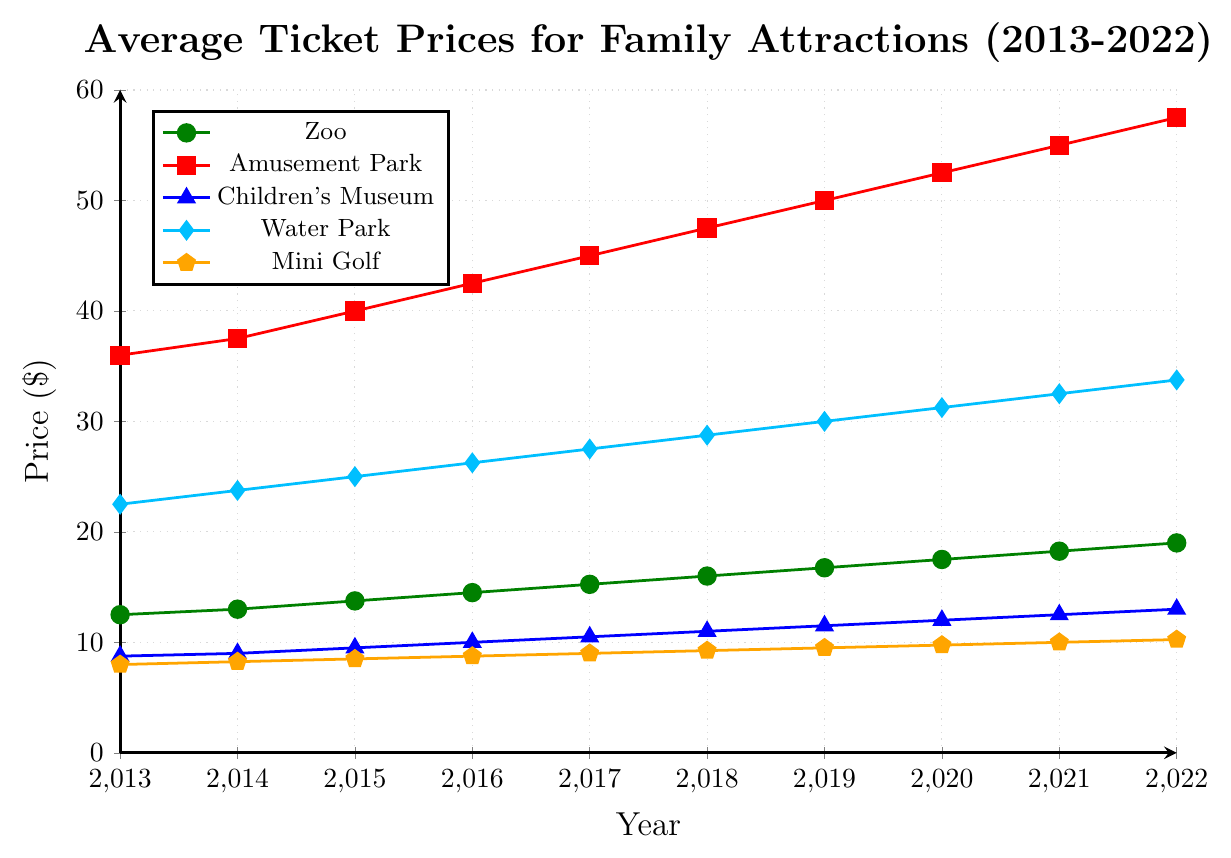What was the overall increase in the average ticket price for the Zoo from 2013 to 2022? The average ticket price for the Zoo in 2013 was $12.50, and it increased to $19.00 in 2022. To find the overall increase, subtract the price in 2013 from the price in 2022: $19.00 - $12.50 = $6.50.
Answer: $6.50 Which type of activity had the highest average ticket price in 2022? By looking at the figure, the Amusement Park had the highest average ticket price in 2022 at $57.50.
Answer: Amusement Park How much did the average ticket price for the Mini Golf increase from 2013 to 2022? The average ticket price for the Mini Golf in 2013 was $7.99, and it increased to $10.25 in 2022. Subtracting the price in 2013 from the price in 2022: $10.25 - $7.99 = $2.26.
Answer: $2.26 Which activity experienced the smallest increase in average ticket price over the decade? By comparing the values from 2013 to 2022 across all activities, the Children's Museum increased from $8.75 to $13.00, which is an increase of $4.25, the smallest among all activities.
Answer: Children's Museum What is the average ticket price for the Water Park in the years 2019 and 2020? The average ticket price for 2019 is $30.00 and for 2020 is $31.25. To find the average of these two years: ($30.00 + $31.25) / 2 = $30.625.
Answer: $30.625 Between which two consecutive years did the Amusement Park ticket prices increase the most? Examining the year-to-year increases in the Amusement Park prices: 
2013-2014: $1.51, 2014-2015: $2.49, 2015-2016: $2.51, 2016-2017: $2.49, 2017-2018: $2.51, 2018-2019: $2.49, 2019-2020: $2.51, 2020-2021: $2.49, 2021-2022: $2.51.
The largest increase occurred between 2015 and 2016 with $2.51.
Answer: 2015-2016 What was the percentage increase in the average ticket price for the Children's Museum from 2013 to 2022? The average ticket price for the Children's Museum in 2013 was $8.75, and it increased to $13.00 in 2022. To find the percentage increase, use the formula: ((13.00 - 8.75) / 8.75) * 100. This calculates to ((4.25 / 8.75) * 100) = 48.57%.
Answer: 48.57% Which activity had a higher average ticket price in 2016: Water Park or Zoo? In 2016, the average ticket price for the Water Park was $26.25, and for the Zoo, it was $14.50. The Water Park had the higher ticket price.
Answer: Water Park By how much did the average ticket price for the Zoo increase each year on average? The average ticket price for the Zoo increased by a total of $6.50 over 10 years. To find the average annual increase, divide the total increase by the number of years: $6.50 / 10 = $0.65.
Answer: $0.65 If we consider only the year 2020, which had a lower average ticket price: Mini Golf or Children's Museum? In 2020, the average ticket price for Mini Golf was $9.75, and for the Children's Museum, it was $12.00. Mini Golf had the lower average ticket price.
Answer: Mini Golf 